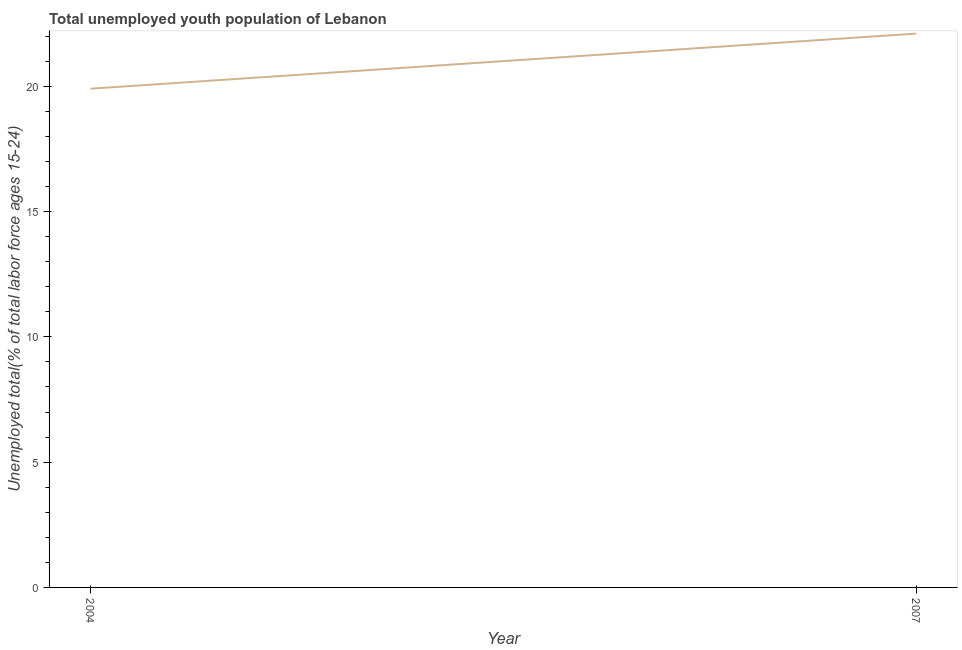What is the unemployed youth in 2007?
Your answer should be compact. 22.1. Across all years, what is the maximum unemployed youth?
Give a very brief answer. 22.1. Across all years, what is the minimum unemployed youth?
Your answer should be compact. 19.9. In which year was the unemployed youth maximum?
Your answer should be compact. 2007. What is the sum of the unemployed youth?
Keep it short and to the point. 42. What is the difference between the unemployed youth in 2004 and 2007?
Offer a very short reply. -2.2. What is the average unemployed youth per year?
Ensure brevity in your answer.  21. What is the median unemployed youth?
Provide a short and direct response. 21. In how many years, is the unemployed youth greater than 14 %?
Your response must be concise. 2. Do a majority of the years between 2004 and 2007 (inclusive) have unemployed youth greater than 20 %?
Ensure brevity in your answer.  No. What is the ratio of the unemployed youth in 2004 to that in 2007?
Give a very brief answer. 0.9. Is the unemployed youth in 2004 less than that in 2007?
Offer a very short reply. Yes. Are the values on the major ticks of Y-axis written in scientific E-notation?
Your answer should be compact. No. Does the graph contain grids?
Your answer should be very brief. No. What is the title of the graph?
Keep it short and to the point. Total unemployed youth population of Lebanon. What is the label or title of the X-axis?
Provide a succinct answer. Year. What is the label or title of the Y-axis?
Provide a short and direct response. Unemployed total(% of total labor force ages 15-24). What is the Unemployed total(% of total labor force ages 15-24) of 2004?
Make the answer very short. 19.9. What is the Unemployed total(% of total labor force ages 15-24) in 2007?
Offer a terse response. 22.1. What is the difference between the Unemployed total(% of total labor force ages 15-24) in 2004 and 2007?
Provide a short and direct response. -2.2. What is the ratio of the Unemployed total(% of total labor force ages 15-24) in 2004 to that in 2007?
Offer a terse response. 0.9. 